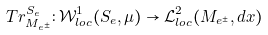Convert formula to latex. <formula><loc_0><loc_0><loc_500><loc_500>T r ^ { S _ { e } } _ { M _ { e ^ { \pm } } } \colon \mathcal { W } ^ { 1 } _ { l o c } ( S _ { e } , \mu ) \rightarrow { \mathcal { L } } ^ { 2 } _ { l o c } ( M _ { e ^ { \pm } } , d x )</formula> 